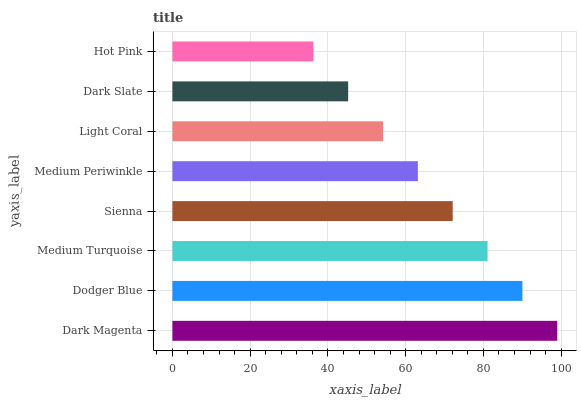Is Hot Pink the minimum?
Answer yes or no. Yes. Is Dark Magenta the maximum?
Answer yes or no. Yes. Is Dodger Blue the minimum?
Answer yes or no. No. Is Dodger Blue the maximum?
Answer yes or no. No. Is Dark Magenta greater than Dodger Blue?
Answer yes or no. Yes. Is Dodger Blue less than Dark Magenta?
Answer yes or no. Yes. Is Dodger Blue greater than Dark Magenta?
Answer yes or no. No. Is Dark Magenta less than Dodger Blue?
Answer yes or no. No. Is Sienna the high median?
Answer yes or no. Yes. Is Medium Periwinkle the low median?
Answer yes or no. Yes. Is Medium Periwinkle the high median?
Answer yes or no. No. Is Hot Pink the low median?
Answer yes or no. No. 